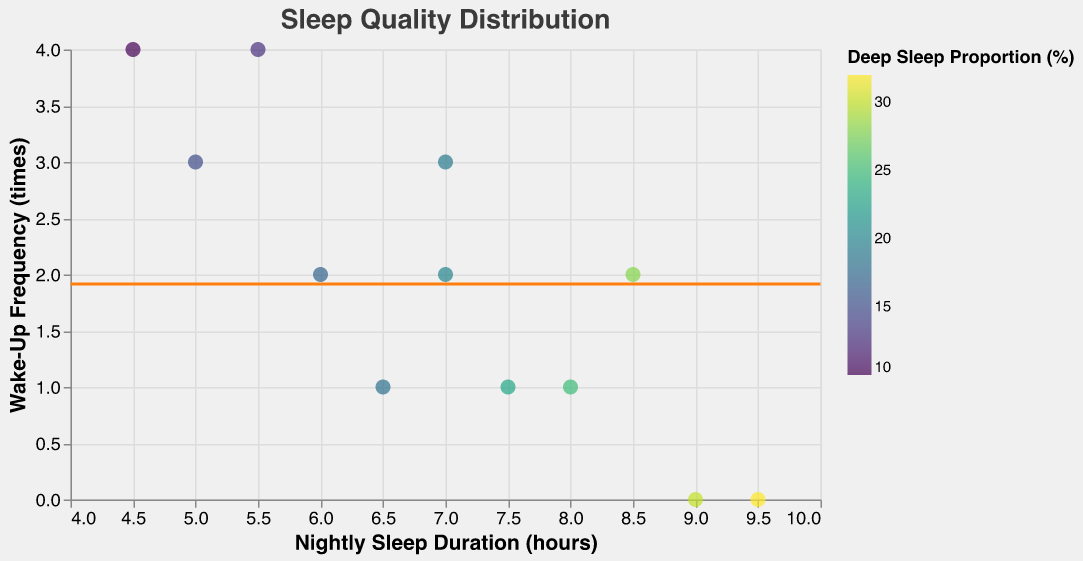What is the title of the figure? The figure title is displayed at the top center of the plot. It reads "Sleep Quality Distribution".
Answer: Sleep Quality Distribution What is the total number of data points on the plot? The plot contains data points representing different sleep qualities. By counting them, we find there are 12 data points.
Answer: 12 Which sleep duration has the highest Deep Sleep Proportion? By examining the color intensity on the plot, the data point at 9.5 hours of nightly sleep duration has the highest deep sleep proportion at 32%.
Answer: 9.5 hours What is the average Wake-Up Frequency? A horizontal rule marks the average Wake-Up Frequency across all data points. This rule intersects the y-axis at approximately 2.17.
Answer: ~2.17 times How many data points have a Wake-Up Frequency of 4 times? Observing the y-axis for points at 4 Wake-Up Frequency reveals two data points, corresponding to 4.5 and 5.5 hours of nightly sleep duration.
Answer: 2 What is the Wake-Up Frequency for the data point with 8 hours of nightly sleep? By locating the data point at 8 hours on the x-axis, we find that it has a Wake-Up Frequency of 1 time.
Answer: 1 time Compare the Deep Sleep Proportion between nightly sleep durations of 5 hours and 7 hours. Which is higher? Observing the deep sleep proportion (color), 5 hours has a proportion of 15%, and 7 hours has proportions of 19% and 20%. Therefore, 7 hours has a higher deep sleep proportion.
Answer: 7 hours What range of sleep durations corresponds to a Wake-Up Frequency of 2 times? On the y-axis at 2 Wake-Up Frequency, the sleep durations range from 6 to 8.5 hours.
Answer: 6 to 8.5 hours Which data point has the highest Wake-Up Frequency and what is its Deep Sleep Proportion? The highest Wake-Up Frequency is 4 times, and the corresponding data points are 4.5 and 5.5 hours. Their Deep Sleep Proportions are 10% and 13%, respectively.
Answer: 4.5 hours: 10%, 5.5 hours: 13% Is there any data point with no Wake-Up Frequency? If yes, what are their nightly sleep durations? Points with 0 Wake-Up Frequency can be identified on the y-axis at 0. These correspond to nightly sleep durations of 9 and 9.5 hours.
Answer: 9 and 9.5 hours 